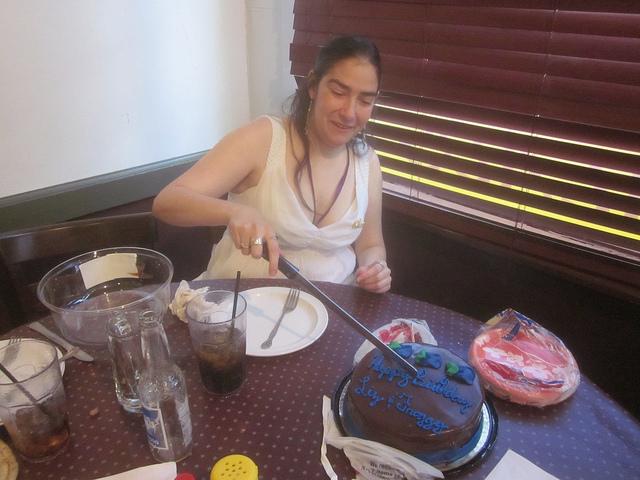What is in the glass?
Give a very brief answer. Soda. Is she sleeping?
Answer briefly. No. What is the woman doing to the cake?
Write a very short answer. Cutting it. What is already on the woman's plate?
Answer briefly. Fork. What color is the writing on the cake?
Short answer required. Blue. 